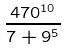<formula> <loc_0><loc_0><loc_500><loc_500>\frac { 4 7 0 ^ { 1 0 } } { 7 + 9 ^ { 5 } }</formula> 